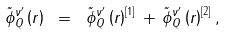<formula> <loc_0><loc_0><loc_500><loc_500>\tilde { \phi } ^ { \nu ^ { \prime } } _ { Q } \left ( r \right ) \ = \ \tilde { \phi } ^ { \nu ^ { \prime } } _ { Q } \left ( r \right ) ^ { [ 1 ] } \, + \, \tilde { \phi } ^ { \nu ^ { \prime } } _ { Q } \left ( r \right ) ^ { [ 2 ] } ,</formula> 